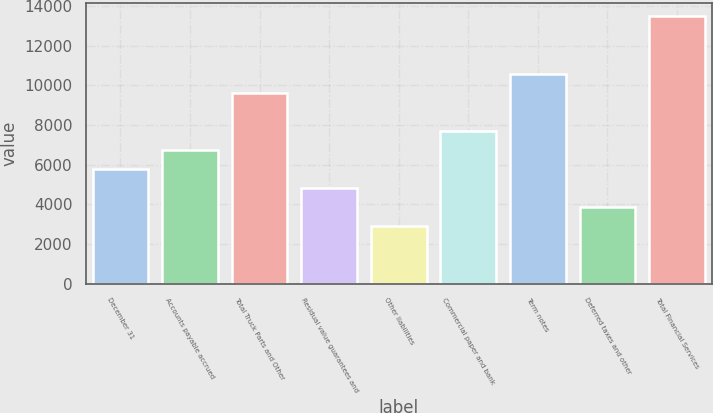Convert chart. <chart><loc_0><loc_0><loc_500><loc_500><bar_chart><fcel>December 31<fcel>Accounts payable accrued<fcel>Total Truck Parts and Other<fcel>Residual value guarantees and<fcel>Other liabilities<fcel>Commercial paper and bank<fcel>Term notes<fcel>Deferred taxes and other<fcel>Total Financial Services<nl><fcel>5787<fcel>6750.05<fcel>9639.2<fcel>4823.95<fcel>2897.85<fcel>7713.1<fcel>10602.2<fcel>3860.9<fcel>13491.4<nl></chart> 